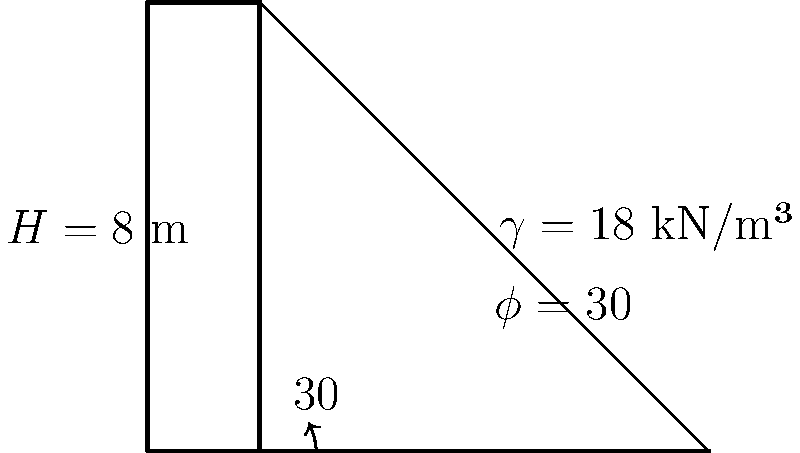As a civil engineer working on a project to improve educational infrastructure, you need to design a retaining wall for a new school building. Given a vertical retaining wall of height $H = 8$ m, supporting a cohesionless soil with an internal friction angle $\phi = 30°$ and unit weight $\gamma = 18$ kN/m³, calculate the active earth pressure at the base of the wall using Rankine's theory. Assume the backfill is horizontal. To calculate the active earth pressure at the base of the retaining wall, we'll follow these steps:

1) First, we need to calculate the active earth pressure coefficient ($K_a$) using Rankine's theory:

   $K_a = \tan^2(45° - \frac{\phi}{2})$
   $K_a = \tan^2(45° - \frac{30°}{2}) = \tan^2(30°) = (\frac{1}{\sqrt{3}})^2 = \frac{1}{3}$

2) Now, we can use the formula for active earth pressure at the base of the wall:

   $P_a = \frac{1}{2} \gamma H^2 K_a$

3) Substituting the given values:

   $P_a = \frac{1}{2} \cdot 18 \text{ kN/m³} \cdot (8 \text{ m})^2 \cdot \frac{1}{3}$

4) Calculating:

   $P_a = \frac{1}{2} \cdot 18 \cdot 64 \cdot \frac{1}{3} = 192 \text{ kN/m²}$

Therefore, the active earth pressure at the base of the wall is 192 kN/m².
Answer: 192 kN/m² 